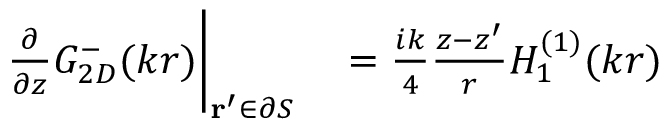<formula> <loc_0><loc_0><loc_500><loc_500>\begin{array} { r l } { \frac { \partial } { \partial z } G _ { 2 D } ^ { - } ( k r ) \Big | _ { r ^ { \prime } \in \partial S } } & = \frac { i k } { 4 } \frac { z - z ^ { \prime } } { r } H _ { 1 } ^ { ( 1 ) } ( k r ) } \end{array}</formula> 